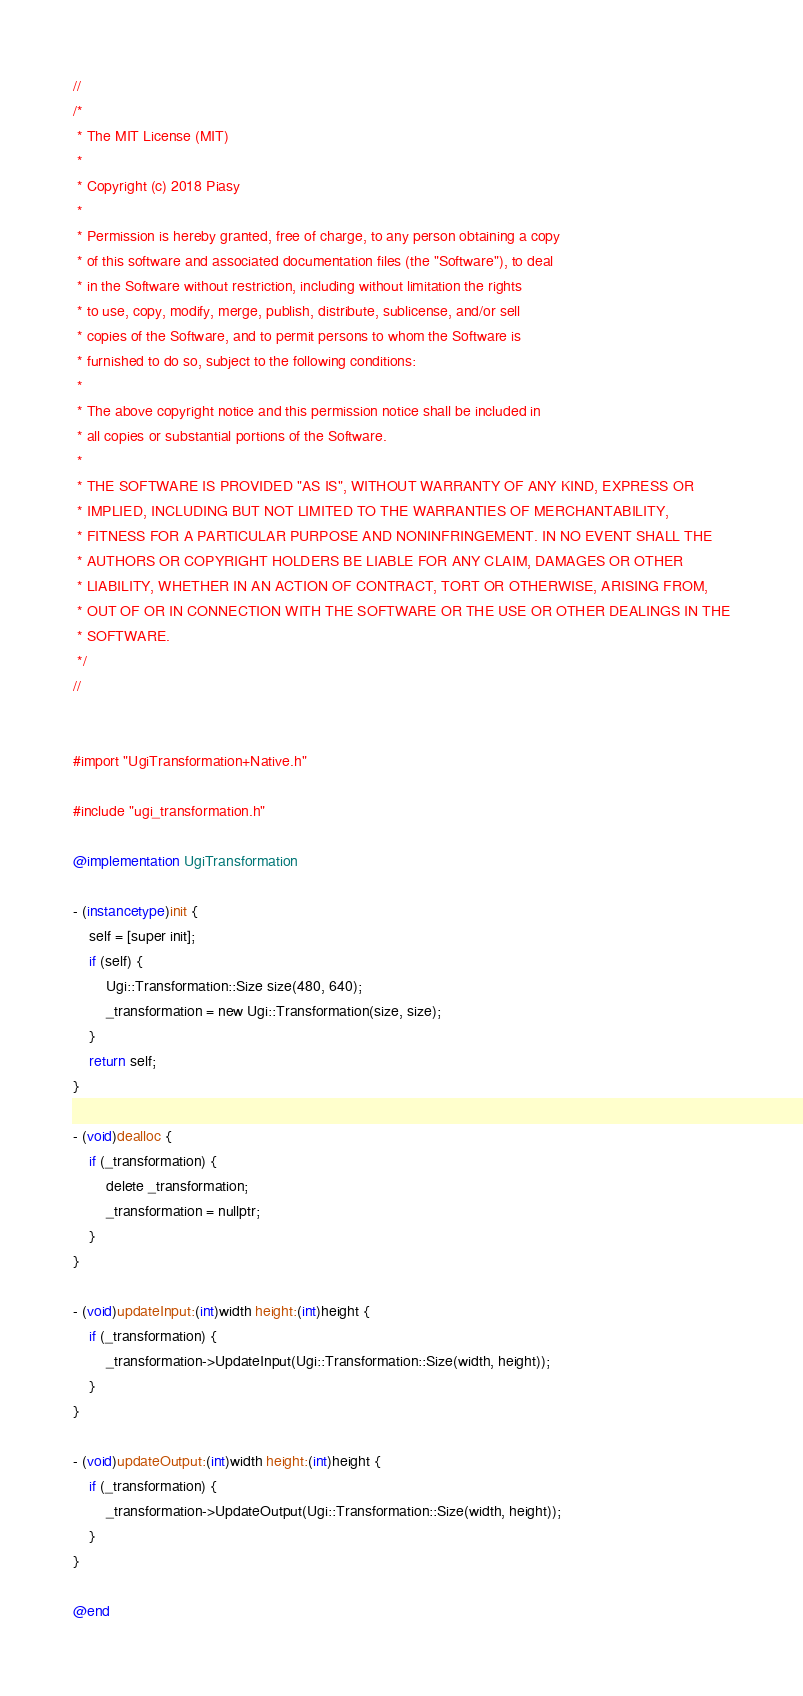Convert code to text. <code><loc_0><loc_0><loc_500><loc_500><_ObjectiveC_>//
/*
 * The MIT License (MIT)
 *
 * Copyright (c) 2018 Piasy
 *
 * Permission is hereby granted, free of charge, to any person obtaining a copy
 * of this software and associated documentation files (the "Software"), to deal
 * in the Software without restriction, including without limitation the rights
 * to use, copy, modify, merge, publish, distribute, sublicense, and/or sell
 * copies of the Software, and to permit persons to whom the Software is
 * furnished to do so, subject to the following conditions:
 *
 * The above copyright notice and this permission notice shall be included in
 * all copies or substantial portions of the Software.
 *
 * THE SOFTWARE IS PROVIDED "AS IS", WITHOUT WARRANTY OF ANY KIND, EXPRESS OR
 * IMPLIED, INCLUDING BUT NOT LIMITED TO THE WARRANTIES OF MERCHANTABILITY,
 * FITNESS FOR A PARTICULAR PURPOSE AND NONINFRINGEMENT. IN NO EVENT SHALL THE
 * AUTHORS OR COPYRIGHT HOLDERS BE LIABLE FOR ANY CLAIM, DAMAGES OR OTHER
 * LIABILITY, WHETHER IN AN ACTION OF CONTRACT, TORT OR OTHERWISE, ARISING FROM,
 * OUT OF OR IN CONNECTION WITH THE SOFTWARE OR THE USE OR OTHER DEALINGS IN THE
 * SOFTWARE.
 */
//


#import "UgiTransformation+Native.h"

#include "ugi_transformation.h"

@implementation UgiTransformation

- (instancetype)init {
    self = [super init];
    if (self) {
        Ugi::Transformation::Size size(480, 640);
        _transformation = new Ugi::Transformation(size, size);
    }
    return self;
}

- (void)dealloc {
    if (_transformation) {
        delete _transformation;
        _transformation = nullptr;
    }
}

- (void)updateInput:(int)width height:(int)height {
    if (_transformation) {
        _transformation->UpdateInput(Ugi::Transformation::Size(width, height));
    }
}

- (void)updateOutput:(int)width height:(int)height {
    if (_transformation) {
        _transformation->UpdateOutput(Ugi::Transformation::Size(width, height));
    }
}

@end
</code> 